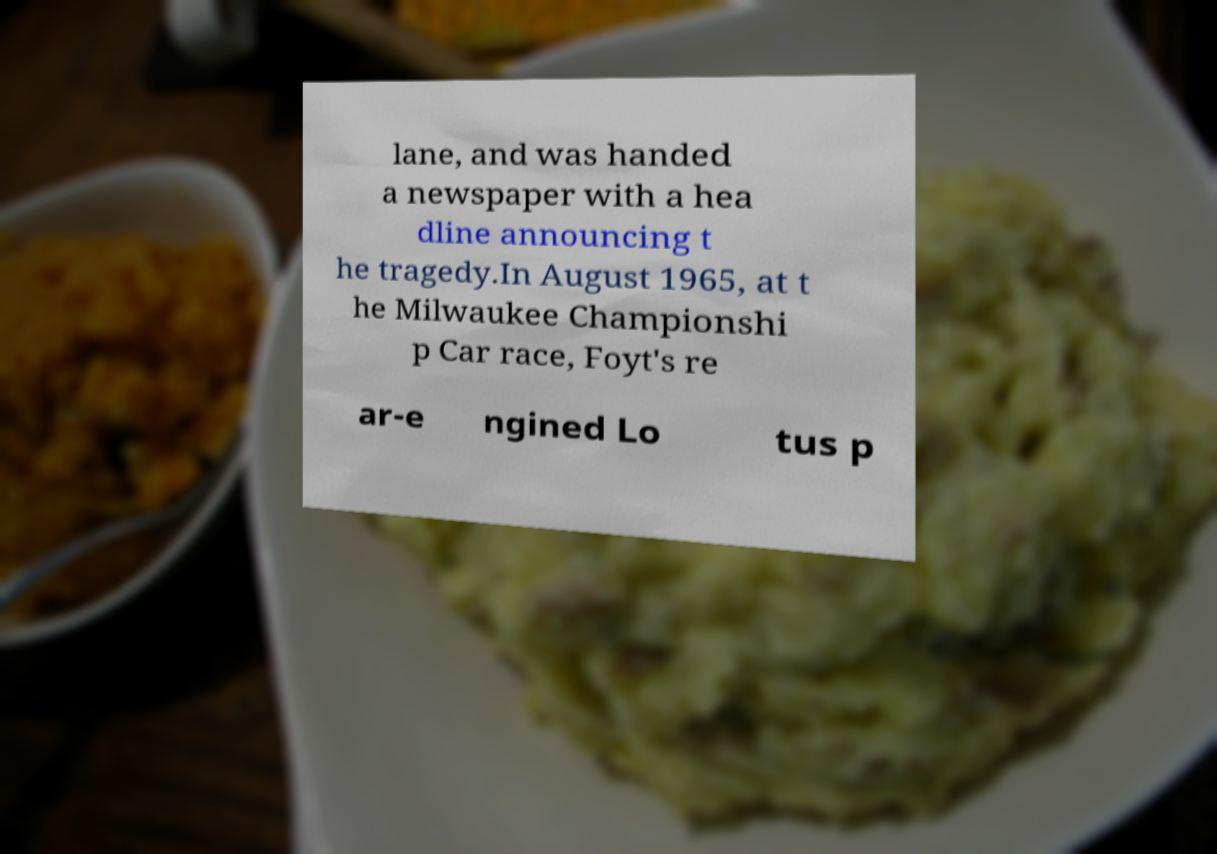Please read and relay the text visible in this image. What does it say? lane, and was handed a newspaper with a hea dline announcing t he tragedy.In August 1965, at t he Milwaukee Championshi p Car race, Foyt's re ar-e ngined Lo tus p 